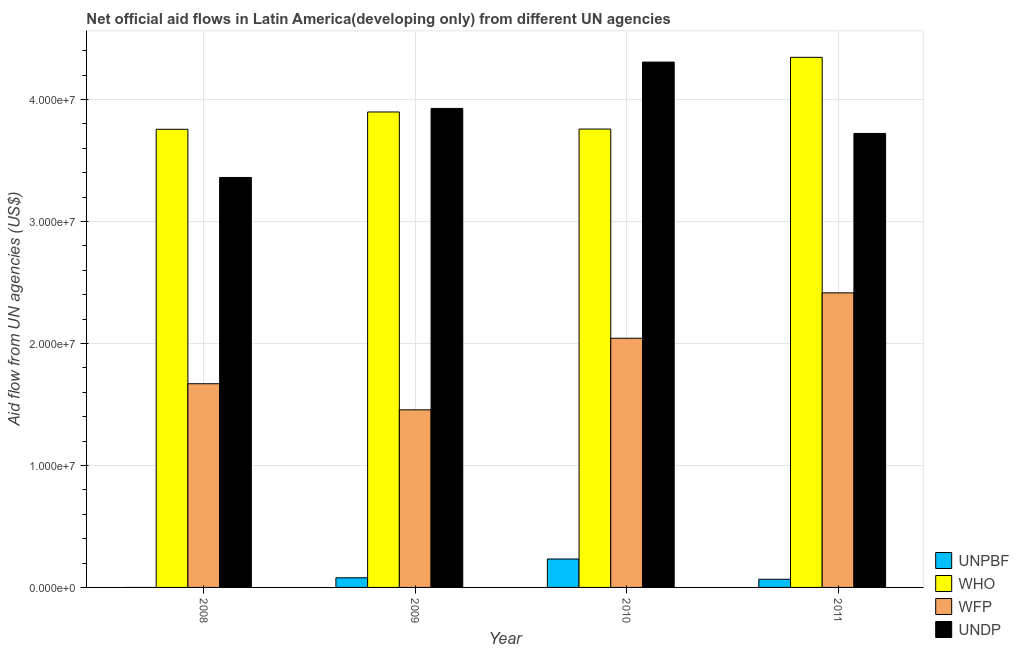How many groups of bars are there?
Ensure brevity in your answer.  4. Are the number of bars per tick equal to the number of legend labels?
Your response must be concise. No. Are the number of bars on each tick of the X-axis equal?
Your answer should be very brief. No. How many bars are there on the 3rd tick from the left?
Keep it short and to the point. 4. How many bars are there on the 3rd tick from the right?
Keep it short and to the point. 4. What is the label of the 1st group of bars from the left?
Your answer should be very brief. 2008. In how many cases, is the number of bars for a given year not equal to the number of legend labels?
Your answer should be compact. 1. What is the amount of aid given by who in 2010?
Offer a very short reply. 3.76e+07. Across all years, what is the maximum amount of aid given by unpbf?
Keep it short and to the point. 2.33e+06. Across all years, what is the minimum amount of aid given by who?
Your answer should be very brief. 3.76e+07. What is the total amount of aid given by wfp in the graph?
Provide a short and direct response. 7.58e+07. What is the difference between the amount of aid given by wfp in 2010 and that in 2011?
Your answer should be very brief. -3.72e+06. What is the difference between the amount of aid given by who in 2009 and the amount of aid given by unpbf in 2011?
Give a very brief answer. -4.48e+06. What is the average amount of aid given by unpbf per year?
Provide a short and direct response. 9.48e+05. In how many years, is the amount of aid given by wfp greater than 14000000 US$?
Your answer should be compact. 4. What is the ratio of the amount of aid given by undp in 2009 to that in 2011?
Your answer should be compact. 1.06. Is the difference between the amount of aid given by undp in 2008 and 2010 greater than the difference between the amount of aid given by unpbf in 2008 and 2010?
Your answer should be very brief. No. What is the difference between the highest and the second highest amount of aid given by who?
Offer a terse response. 4.48e+06. What is the difference between the highest and the lowest amount of aid given by undp?
Ensure brevity in your answer.  9.46e+06. Is it the case that in every year, the sum of the amount of aid given by undp and amount of aid given by who is greater than the sum of amount of aid given by wfp and amount of aid given by unpbf?
Offer a very short reply. No. Is it the case that in every year, the sum of the amount of aid given by unpbf and amount of aid given by who is greater than the amount of aid given by wfp?
Your answer should be compact. Yes. How many bars are there?
Offer a very short reply. 15. Are all the bars in the graph horizontal?
Offer a very short reply. No. Does the graph contain grids?
Provide a succinct answer. Yes. How many legend labels are there?
Keep it short and to the point. 4. What is the title of the graph?
Ensure brevity in your answer.  Net official aid flows in Latin America(developing only) from different UN agencies. Does "Quality of public administration" appear as one of the legend labels in the graph?
Your answer should be compact. No. What is the label or title of the X-axis?
Keep it short and to the point. Year. What is the label or title of the Y-axis?
Your answer should be very brief. Aid flow from UN agencies (US$). What is the Aid flow from UN agencies (US$) of WHO in 2008?
Give a very brief answer. 3.76e+07. What is the Aid flow from UN agencies (US$) in WFP in 2008?
Make the answer very short. 1.67e+07. What is the Aid flow from UN agencies (US$) of UNDP in 2008?
Give a very brief answer. 3.36e+07. What is the Aid flow from UN agencies (US$) in UNPBF in 2009?
Your response must be concise. 7.90e+05. What is the Aid flow from UN agencies (US$) of WHO in 2009?
Provide a short and direct response. 3.90e+07. What is the Aid flow from UN agencies (US$) in WFP in 2009?
Offer a very short reply. 1.46e+07. What is the Aid flow from UN agencies (US$) in UNDP in 2009?
Provide a short and direct response. 3.93e+07. What is the Aid flow from UN agencies (US$) in UNPBF in 2010?
Your response must be concise. 2.33e+06. What is the Aid flow from UN agencies (US$) of WHO in 2010?
Your response must be concise. 3.76e+07. What is the Aid flow from UN agencies (US$) of WFP in 2010?
Your response must be concise. 2.04e+07. What is the Aid flow from UN agencies (US$) in UNDP in 2010?
Provide a succinct answer. 4.31e+07. What is the Aid flow from UN agencies (US$) in UNPBF in 2011?
Your answer should be compact. 6.70e+05. What is the Aid flow from UN agencies (US$) of WHO in 2011?
Make the answer very short. 4.35e+07. What is the Aid flow from UN agencies (US$) of WFP in 2011?
Make the answer very short. 2.42e+07. What is the Aid flow from UN agencies (US$) in UNDP in 2011?
Make the answer very short. 3.72e+07. Across all years, what is the maximum Aid flow from UN agencies (US$) in UNPBF?
Provide a succinct answer. 2.33e+06. Across all years, what is the maximum Aid flow from UN agencies (US$) of WHO?
Offer a terse response. 4.35e+07. Across all years, what is the maximum Aid flow from UN agencies (US$) in WFP?
Provide a short and direct response. 2.42e+07. Across all years, what is the maximum Aid flow from UN agencies (US$) in UNDP?
Your response must be concise. 4.31e+07. Across all years, what is the minimum Aid flow from UN agencies (US$) of UNPBF?
Keep it short and to the point. 0. Across all years, what is the minimum Aid flow from UN agencies (US$) in WHO?
Your response must be concise. 3.76e+07. Across all years, what is the minimum Aid flow from UN agencies (US$) in WFP?
Your answer should be compact. 1.46e+07. Across all years, what is the minimum Aid flow from UN agencies (US$) of UNDP?
Give a very brief answer. 3.36e+07. What is the total Aid flow from UN agencies (US$) in UNPBF in the graph?
Ensure brevity in your answer.  3.79e+06. What is the total Aid flow from UN agencies (US$) in WHO in the graph?
Keep it short and to the point. 1.58e+08. What is the total Aid flow from UN agencies (US$) in WFP in the graph?
Provide a succinct answer. 7.58e+07. What is the total Aid flow from UN agencies (US$) of UNDP in the graph?
Offer a very short reply. 1.53e+08. What is the difference between the Aid flow from UN agencies (US$) in WHO in 2008 and that in 2009?
Provide a succinct answer. -1.42e+06. What is the difference between the Aid flow from UN agencies (US$) in WFP in 2008 and that in 2009?
Provide a succinct answer. 2.14e+06. What is the difference between the Aid flow from UN agencies (US$) in UNDP in 2008 and that in 2009?
Offer a terse response. -5.66e+06. What is the difference between the Aid flow from UN agencies (US$) in WHO in 2008 and that in 2010?
Your answer should be very brief. -2.00e+04. What is the difference between the Aid flow from UN agencies (US$) of WFP in 2008 and that in 2010?
Your answer should be very brief. -3.73e+06. What is the difference between the Aid flow from UN agencies (US$) in UNDP in 2008 and that in 2010?
Your response must be concise. -9.46e+06. What is the difference between the Aid flow from UN agencies (US$) of WHO in 2008 and that in 2011?
Make the answer very short. -5.90e+06. What is the difference between the Aid flow from UN agencies (US$) of WFP in 2008 and that in 2011?
Ensure brevity in your answer.  -7.45e+06. What is the difference between the Aid flow from UN agencies (US$) in UNDP in 2008 and that in 2011?
Offer a very short reply. -3.61e+06. What is the difference between the Aid flow from UN agencies (US$) in UNPBF in 2009 and that in 2010?
Provide a succinct answer. -1.54e+06. What is the difference between the Aid flow from UN agencies (US$) of WHO in 2009 and that in 2010?
Give a very brief answer. 1.40e+06. What is the difference between the Aid flow from UN agencies (US$) in WFP in 2009 and that in 2010?
Provide a short and direct response. -5.87e+06. What is the difference between the Aid flow from UN agencies (US$) of UNDP in 2009 and that in 2010?
Ensure brevity in your answer.  -3.80e+06. What is the difference between the Aid flow from UN agencies (US$) of WHO in 2009 and that in 2011?
Keep it short and to the point. -4.48e+06. What is the difference between the Aid flow from UN agencies (US$) in WFP in 2009 and that in 2011?
Offer a very short reply. -9.59e+06. What is the difference between the Aid flow from UN agencies (US$) of UNDP in 2009 and that in 2011?
Offer a terse response. 2.05e+06. What is the difference between the Aid flow from UN agencies (US$) in UNPBF in 2010 and that in 2011?
Provide a short and direct response. 1.66e+06. What is the difference between the Aid flow from UN agencies (US$) in WHO in 2010 and that in 2011?
Make the answer very short. -5.88e+06. What is the difference between the Aid flow from UN agencies (US$) of WFP in 2010 and that in 2011?
Offer a very short reply. -3.72e+06. What is the difference between the Aid flow from UN agencies (US$) in UNDP in 2010 and that in 2011?
Ensure brevity in your answer.  5.85e+06. What is the difference between the Aid flow from UN agencies (US$) of WHO in 2008 and the Aid flow from UN agencies (US$) of WFP in 2009?
Your answer should be compact. 2.30e+07. What is the difference between the Aid flow from UN agencies (US$) in WHO in 2008 and the Aid flow from UN agencies (US$) in UNDP in 2009?
Keep it short and to the point. -1.71e+06. What is the difference between the Aid flow from UN agencies (US$) of WFP in 2008 and the Aid flow from UN agencies (US$) of UNDP in 2009?
Provide a short and direct response. -2.26e+07. What is the difference between the Aid flow from UN agencies (US$) in WHO in 2008 and the Aid flow from UN agencies (US$) in WFP in 2010?
Provide a short and direct response. 1.71e+07. What is the difference between the Aid flow from UN agencies (US$) in WHO in 2008 and the Aid flow from UN agencies (US$) in UNDP in 2010?
Offer a very short reply. -5.51e+06. What is the difference between the Aid flow from UN agencies (US$) in WFP in 2008 and the Aid flow from UN agencies (US$) in UNDP in 2010?
Your response must be concise. -2.64e+07. What is the difference between the Aid flow from UN agencies (US$) of WHO in 2008 and the Aid flow from UN agencies (US$) of WFP in 2011?
Give a very brief answer. 1.34e+07. What is the difference between the Aid flow from UN agencies (US$) of WHO in 2008 and the Aid flow from UN agencies (US$) of UNDP in 2011?
Give a very brief answer. 3.40e+05. What is the difference between the Aid flow from UN agencies (US$) of WFP in 2008 and the Aid flow from UN agencies (US$) of UNDP in 2011?
Make the answer very short. -2.05e+07. What is the difference between the Aid flow from UN agencies (US$) in UNPBF in 2009 and the Aid flow from UN agencies (US$) in WHO in 2010?
Provide a short and direct response. -3.68e+07. What is the difference between the Aid flow from UN agencies (US$) in UNPBF in 2009 and the Aid flow from UN agencies (US$) in WFP in 2010?
Offer a very short reply. -1.96e+07. What is the difference between the Aid flow from UN agencies (US$) of UNPBF in 2009 and the Aid flow from UN agencies (US$) of UNDP in 2010?
Offer a terse response. -4.23e+07. What is the difference between the Aid flow from UN agencies (US$) of WHO in 2009 and the Aid flow from UN agencies (US$) of WFP in 2010?
Your answer should be compact. 1.86e+07. What is the difference between the Aid flow from UN agencies (US$) in WHO in 2009 and the Aid flow from UN agencies (US$) in UNDP in 2010?
Offer a terse response. -4.09e+06. What is the difference between the Aid flow from UN agencies (US$) in WFP in 2009 and the Aid flow from UN agencies (US$) in UNDP in 2010?
Provide a short and direct response. -2.85e+07. What is the difference between the Aid flow from UN agencies (US$) of UNPBF in 2009 and the Aid flow from UN agencies (US$) of WHO in 2011?
Make the answer very short. -4.27e+07. What is the difference between the Aid flow from UN agencies (US$) in UNPBF in 2009 and the Aid flow from UN agencies (US$) in WFP in 2011?
Your answer should be very brief. -2.34e+07. What is the difference between the Aid flow from UN agencies (US$) in UNPBF in 2009 and the Aid flow from UN agencies (US$) in UNDP in 2011?
Ensure brevity in your answer.  -3.64e+07. What is the difference between the Aid flow from UN agencies (US$) of WHO in 2009 and the Aid flow from UN agencies (US$) of WFP in 2011?
Provide a short and direct response. 1.48e+07. What is the difference between the Aid flow from UN agencies (US$) of WHO in 2009 and the Aid flow from UN agencies (US$) of UNDP in 2011?
Offer a very short reply. 1.76e+06. What is the difference between the Aid flow from UN agencies (US$) in WFP in 2009 and the Aid flow from UN agencies (US$) in UNDP in 2011?
Offer a terse response. -2.27e+07. What is the difference between the Aid flow from UN agencies (US$) of UNPBF in 2010 and the Aid flow from UN agencies (US$) of WHO in 2011?
Your answer should be compact. -4.11e+07. What is the difference between the Aid flow from UN agencies (US$) of UNPBF in 2010 and the Aid flow from UN agencies (US$) of WFP in 2011?
Your answer should be very brief. -2.18e+07. What is the difference between the Aid flow from UN agencies (US$) in UNPBF in 2010 and the Aid flow from UN agencies (US$) in UNDP in 2011?
Make the answer very short. -3.49e+07. What is the difference between the Aid flow from UN agencies (US$) in WHO in 2010 and the Aid flow from UN agencies (US$) in WFP in 2011?
Offer a very short reply. 1.34e+07. What is the difference between the Aid flow from UN agencies (US$) in WFP in 2010 and the Aid flow from UN agencies (US$) in UNDP in 2011?
Provide a short and direct response. -1.68e+07. What is the average Aid flow from UN agencies (US$) in UNPBF per year?
Ensure brevity in your answer.  9.48e+05. What is the average Aid flow from UN agencies (US$) in WHO per year?
Give a very brief answer. 3.94e+07. What is the average Aid flow from UN agencies (US$) of WFP per year?
Give a very brief answer. 1.90e+07. What is the average Aid flow from UN agencies (US$) in UNDP per year?
Ensure brevity in your answer.  3.83e+07. In the year 2008, what is the difference between the Aid flow from UN agencies (US$) of WHO and Aid flow from UN agencies (US$) of WFP?
Your answer should be very brief. 2.09e+07. In the year 2008, what is the difference between the Aid flow from UN agencies (US$) in WHO and Aid flow from UN agencies (US$) in UNDP?
Offer a terse response. 3.95e+06. In the year 2008, what is the difference between the Aid flow from UN agencies (US$) of WFP and Aid flow from UN agencies (US$) of UNDP?
Offer a terse response. -1.69e+07. In the year 2009, what is the difference between the Aid flow from UN agencies (US$) in UNPBF and Aid flow from UN agencies (US$) in WHO?
Provide a short and direct response. -3.82e+07. In the year 2009, what is the difference between the Aid flow from UN agencies (US$) in UNPBF and Aid flow from UN agencies (US$) in WFP?
Provide a short and direct response. -1.38e+07. In the year 2009, what is the difference between the Aid flow from UN agencies (US$) of UNPBF and Aid flow from UN agencies (US$) of UNDP?
Your answer should be very brief. -3.85e+07. In the year 2009, what is the difference between the Aid flow from UN agencies (US$) in WHO and Aid flow from UN agencies (US$) in WFP?
Offer a terse response. 2.44e+07. In the year 2009, what is the difference between the Aid flow from UN agencies (US$) of WHO and Aid flow from UN agencies (US$) of UNDP?
Offer a very short reply. -2.90e+05. In the year 2009, what is the difference between the Aid flow from UN agencies (US$) in WFP and Aid flow from UN agencies (US$) in UNDP?
Keep it short and to the point. -2.47e+07. In the year 2010, what is the difference between the Aid flow from UN agencies (US$) in UNPBF and Aid flow from UN agencies (US$) in WHO?
Your answer should be very brief. -3.52e+07. In the year 2010, what is the difference between the Aid flow from UN agencies (US$) in UNPBF and Aid flow from UN agencies (US$) in WFP?
Give a very brief answer. -1.81e+07. In the year 2010, what is the difference between the Aid flow from UN agencies (US$) of UNPBF and Aid flow from UN agencies (US$) of UNDP?
Make the answer very short. -4.07e+07. In the year 2010, what is the difference between the Aid flow from UN agencies (US$) of WHO and Aid flow from UN agencies (US$) of WFP?
Offer a very short reply. 1.72e+07. In the year 2010, what is the difference between the Aid flow from UN agencies (US$) of WHO and Aid flow from UN agencies (US$) of UNDP?
Your answer should be very brief. -5.49e+06. In the year 2010, what is the difference between the Aid flow from UN agencies (US$) in WFP and Aid flow from UN agencies (US$) in UNDP?
Offer a terse response. -2.26e+07. In the year 2011, what is the difference between the Aid flow from UN agencies (US$) in UNPBF and Aid flow from UN agencies (US$) in WHO?
Your response must be concise. -4.28e+07. In the year 2011, what is the difference between the Aid flow from UN agencies (US$) in UNPBF and Aid flow from UN agencies (US$) in WFP?
Offer a terse response. -2.35e+07. In the year 2011, what is the difference between the Aid flow from UN agencies (US$) of UNPBF and Aid flow from UN agencies (US$) of UNDP?
Provide a short and direct response. -3.66e+07. In the year 2011, what is the difference between the Aid flow from UN agencies (US$) in WHO and Aid flow from UN agencies (US$) in WFP?
Make the answer very short. 1.93e+07. In the year 2011, what is the difference between the Aid flow from UN agencies (US$) in WHO and Aid flow from UN agencies (US$) in UNDP?
Your answer should be compact. 6.24e+06. In the year 2011, what is the difference between the Aid flow from UN agencies (US$) in WFP and Aid flow from UN agencies (US$) in UNDP?
Offer a very short reply. -1.31e+07. What is the ratio of the Aid flow from UN agencies (US$) in WHO in 2008 to that in 2009?
Provide a succinct answer. 0.96. What is the ratio of the Aid flow from UN agencies (US$) in WFP in 2008 to that in 2009?
Your answer should be compact. 1.15. What is the ratio of the Aid flow from UN agencies (US$) in UNDP in 2008 to that in 2009?
Keep it short and to the point. 0.86. What is the ratio of the Aid flow from UN agencies (US$) in WHO in 2008 to that in 2010?
Provide a succinct answer. 1. What is the ratio of the Aid flow from UN agencies (US$) of WFP in 2008 to that in 2010?
Make the answer very short. 0.82. What is the ratio of the Aid flow from UN agencies (US$) in UNDP in 2008 to that in 2010?
Offer a very short reply. 0.78. What is the ratio of the Aid flow from UN agencies (US$) of WHO in 2008 to that in 2011?
Your answer should be compact. 0.86. What is the ratio of the Aid flow from UN agencies (US$) in WFP in 2008 to that in 2011?
Offer a very short reply. 0.69. What is the ratio of the Aid flow from UN agencies (US$) in UNDP in 2008 to that in 2011?
Give a very brief answer. 0.9. What is the ratio of the Aid flow from UN agencies (US$) in UNPBF in 2009 to that in 2010?
Make the answer very short. 0.34. What is the ratio of the Aid flow from UN agencies (US$) of WHO in 2009 to that in 2010?
Your response must be concise. 1.04. What is the ratio of the Aid flow from UN agencies (US$) of WFP in 2009 to that in 2010?
Your answer should be very brief. 0.71. What is the ratio of the Aid flow from UN agencies (US$) in UNDP in 2009 to that in 2010?
Offer a very short reply. 0.91. What is the ratio of the Aid flow from UN agencies (US$) of UNPBF in 2009 to that in 2011?
Give a very brief answer. 1.18. What is the ratio of the Aid flow from UN agencies (US$) in WHO in 2009 to that in 2011?
Provide a short and direct response. 0.9. What is the ratio of the Aid flow from UN agencies (US$) of WFP in 2009 to that in 2011?
Your response must be concise. 0.6. What is the ratio of the Aid flow from UN agencies (US$) in UNDP in 2009 to that in 2011?
Offer a terse response. 1.06. What is the ratio of the Aid flow from UN agencies (US$) in UNPBF in 2010 to that in 2011?
Your answer should be compact. 3.48. What is the ratio of the Aid flow from UN agencies (US$) of WHO in 2010 to that in 2011?
Your answer should be compact. 0.86. What is the ratio of the Aid flow from UN agencies (US$) in WFP in 2010 to that in 2011?
Provide a short and direct response. 0.85. What is the ratio of the Aid flow from UN agencies (US$) of UNDP in 2010 to that in 2011?
Provide a succinct answer. 1.16. What is the difference between the highest and the second highest Aid flow from UN agencies (US$) in UNPBF?
Make the answer very short. 1.54e+06. What is the difference between the highest and the second highest Aid flow from UN agencies (US$) of WHO?
Provide a succinct answer. 4.48e+06. What is the difference between the highest and the second highest Aid flow from UN agencies (US$) of WFP?
Keep it short and to the point. 3.72e+06. What is the difference between the highest and the second highest Aid flow from UN agencies (US$) in UNDP?
Offer a terse response. 3.80e+06. What is the difference between the highest and the lowest Aid flow from UN agencies (US$) of UNPBF?
Offer a terse response. 2.33e+06. What is the difference between the highest and the lowest Aid flow from UN agencies (US$) in WHO?
Your answer should be compact. 5.90e+06. What is the difference between the highest and the lowest Aid flow from UN agencies (US$) in WFP?
Provide a short and direct response. 9.59e+06. What is the difference between the highest and the lowest Aid flow from UN agencies (US$) in UNDP?
Offer a very short reply. 9.46e+06. 